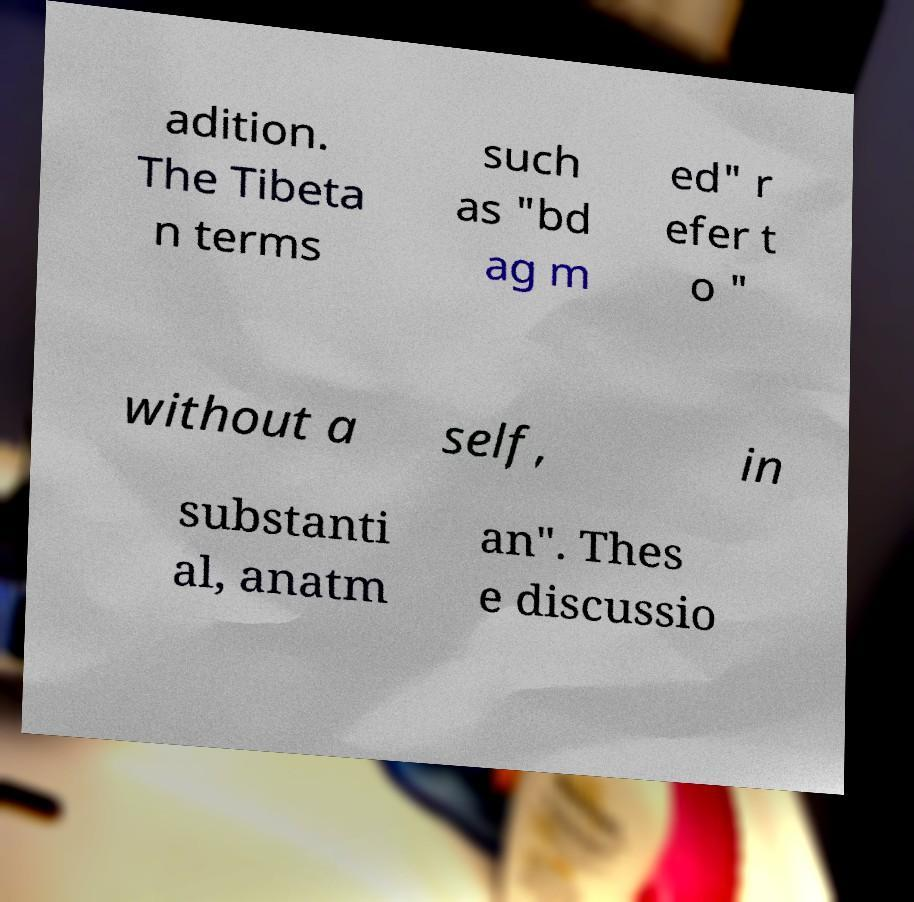I need the written content from this picture converted into text. Can you do that? adition. The Tibeta n terms such as "bd ag m ed" r efer t o " without a self, in substanti al, anatm an". Thes e discussio 